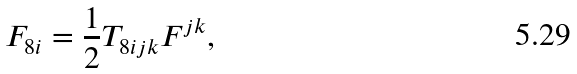<formula> <loc_0><loc_0><loc_500><loc_500>F _ { 8 i } = \frac { 1 } { 2 } T _ { 8 i j k } F ^ { j k } ,</formula> 